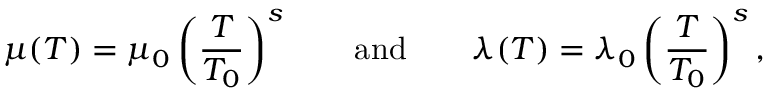Convert formula to latex. <formula><loc_0><loc_0><loc_500><loc_500>\mu ( T ) = \mu _ { 0 } \left ( \frac { T } { T _ { 0 } } \right ) ^ { s } \quad a n d \quad \lambda ( T ) = \lambda _ { 0 } \left ( \frac { T } { T _ { 0 } } \right ) ^ { s } ,</formula> 